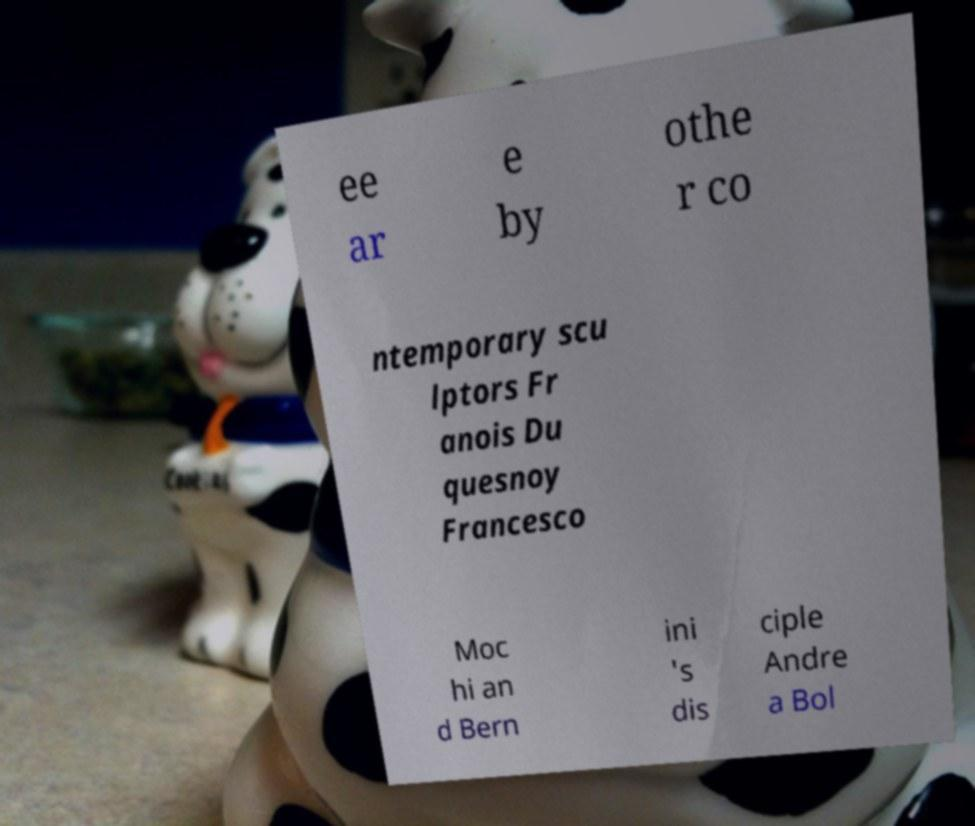Please identify and transcribe the text found in this image. ee ar e by othe r co ntemporary scu lptors Fr anois Du quesnoy Francesco Moc hi an d Bern ini 's dis ciple Andre a Bol 